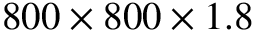<formula> <loc_0><loc_0><loc_500><loc_500>8 0 0 \times 8 0 0 \times 1 . 8</formula> 